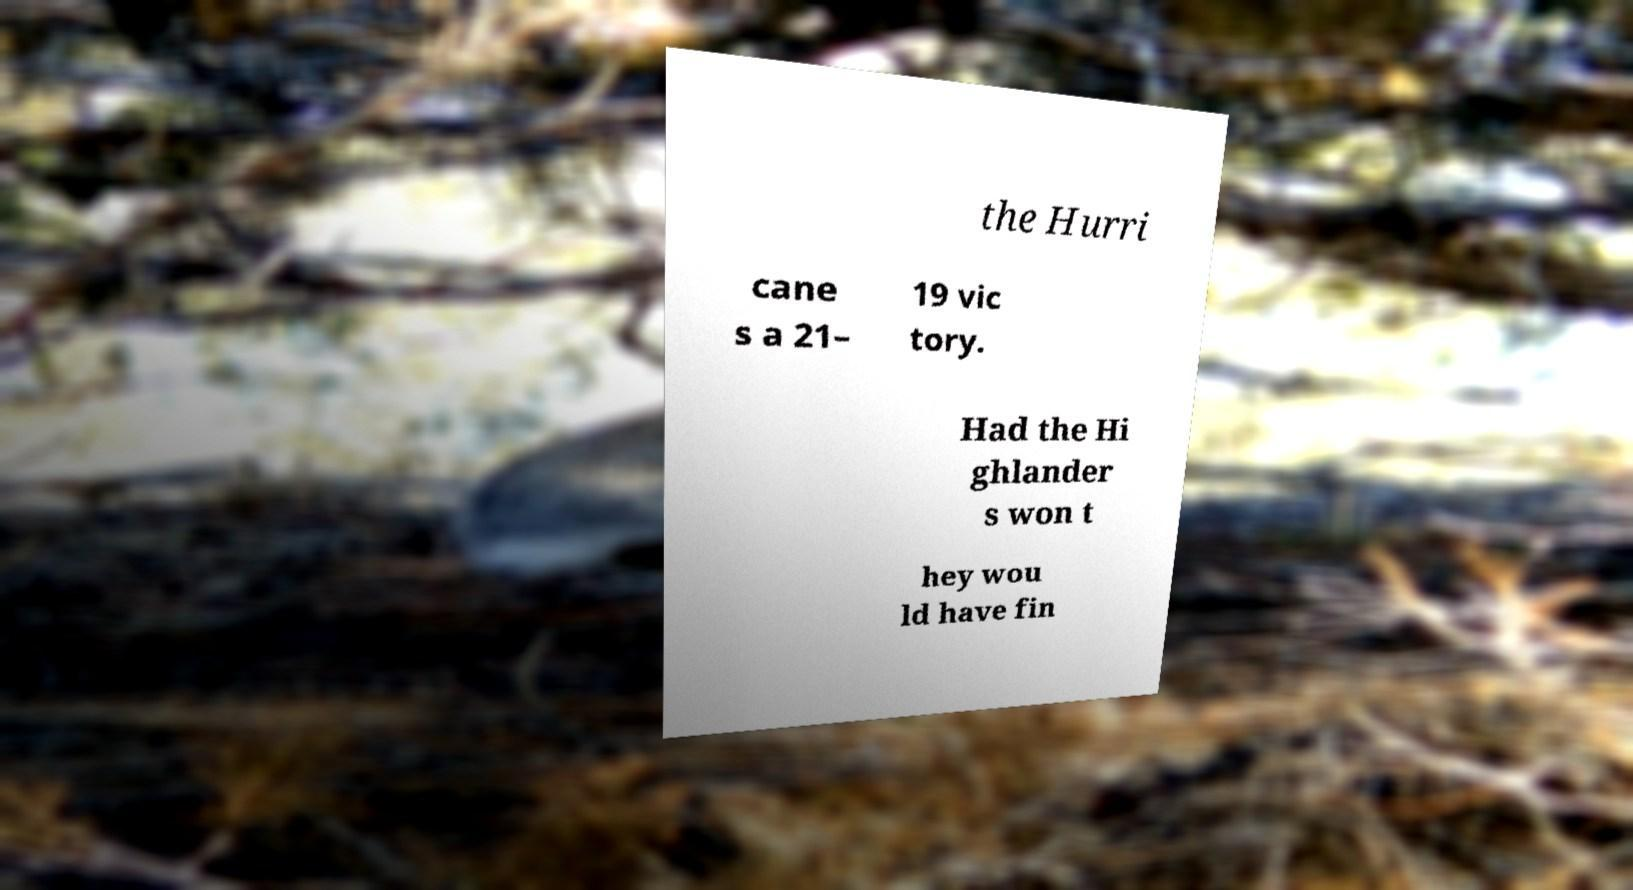Can you read and provide the text displayed in the image?This photo seems to have some interesting text. Can you extract and type it out for me? the Hurri cane s a 21– 19 vic tory. Had the Hi ghlander s won t hey wou ld have fin 